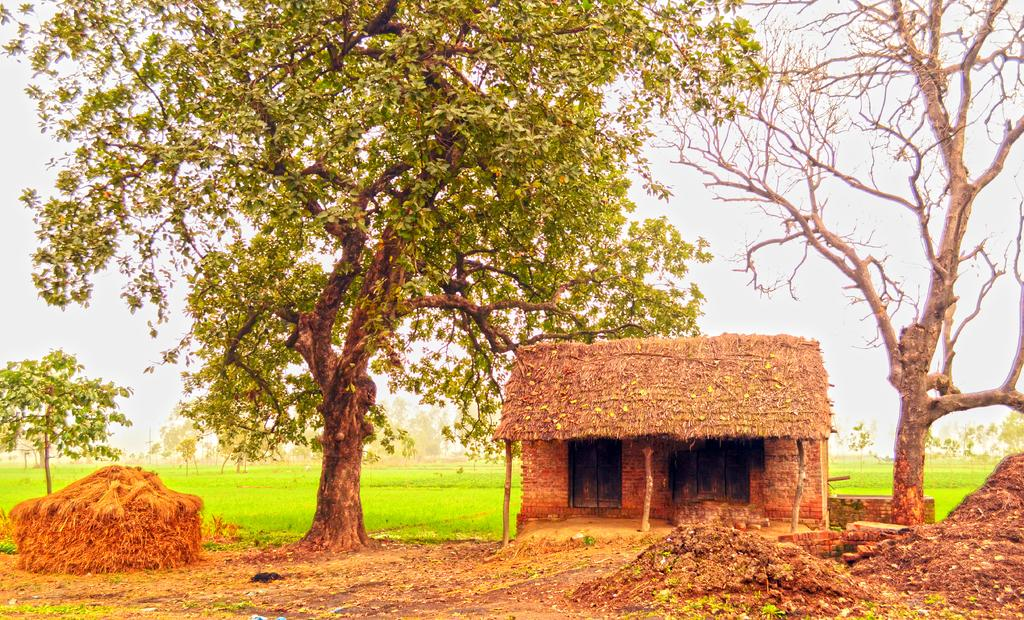What type of structure is visible in the image? There is a hut in the image. What type of vegetation can be seen in the image? There is grass and trees in the image. What is the texture of the ground in the image? Dust is present in the image, which suggests a dry or dusty ground. What is visible in the background of the image? The sky is visible in the image. What type of ink can be seen on the hut in the image? There is no ink present on the hut in the image. How does the hut defend itself from an attack in the image? The image does not depict any attack or defensive measures; it simply shows a hut in a natural setting. 